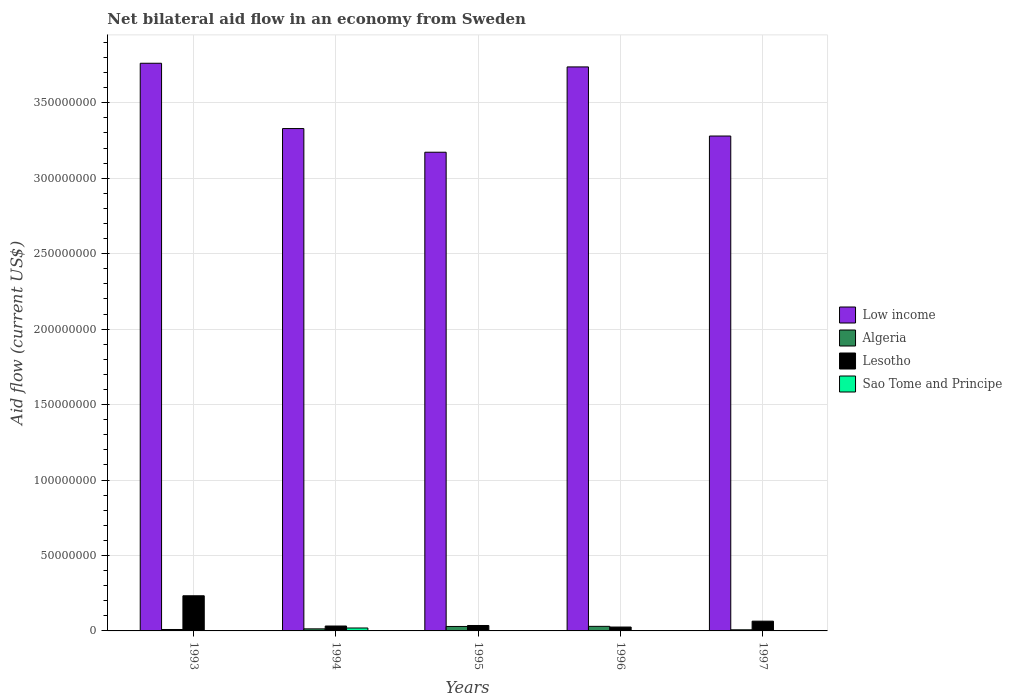How many different coloured bars are there?
Offer a terse response. 4. How many groups of bars are there?
Your answer should be compact. 5. How many bars are there on the 2nd tick from the left?
Provide a succinct answer. 4. How many bars are there on the 5th tick from the right?
Give a very brief answer. 4. In how many cases, is the number of bars for a given year not equal to the number of legend labels?
Offer a very short reply. 0. What is the net bilateral aid flow in Algeria in 1996?
Keep it short and to the point. 3.03e+06. Across all years, what is the maximum net bilateral aid flow in Low income?
Keep it short and to the point. 3.76e+08. Across all years, what is the minimum net bilateral aid flow in Low income?
Ensure brevity in your answer.  3.17e+08. In which year was the net bilateral aid flow in Sao Tome and Principe minimum?
Provide a succinct answer. 1993. What is the total net bilateral aid flow in Sao Tome and Principe in the graph?
Keep it short and to the point. 2.18e+06. What is the difference between the net bilateral aid flow in Sao Tome and Principe in 1993 and that in 1995?
Offer a very short reply. -4.00e+04. What is the difference between the net bilateral aid flow in Algeria in 1996 and the net bilateral aid flow in Low income in 1995?
Keep it short and to the point. -3.14e+08. What is the average net bilateral aid flow in Sao Tome and Principe per year?
Offer a very short reply. 4.36e+05. In the year 1994, what is the difference between the net bilateral aid flow in Algeria and net bilateral aid flow in Low income?
Provide a succinct answer. -3.32e+08. In how many years, is the net bilateral aid flow in Sao Tome and Principe greater than 80000000 US$?
Provide a succinct answer. 0. What is the ratio of the net bilateral aid flow in Algeria in 1993 to that in 1996?
Your answer should be very brief. 0.31. Is the net bilateral aid flow in Algeria in 1994 less than that in 1997?
Your answer should be compact. No. What is the difference between the highest and the second highest net bilateral aid flow in Lesotho?
Give a very brief answer. 1.68e+07. What is the difference between the highest and the lowest net bilateral aid flow in Low income?
Your response must be concise. 5.90e+07. Is the sum of the net bilateral aid flow in Algeria in 1994 and 1995 greater than the maximum net bilateral aid flow in Low income across all years?
Your answer should be compact. No. What does the 3rd bar from the left in 1994 represents?
Offer a terse response. Lesotho. What does the 3rd bar from the right in 1997 represents?
Give a very brief answer. Algeria. Are all the bars in the graph horizontal?
Offer a terse response. No. How many years are there in the graph?
Provide a short and direct response. 5. What is the difference between two consecutive major ticks on the Y-axis?
Keep it short and to the point. 5.00e+07. Are the values on the major ticks of Y-axis written in scientific E-notation?
Your answer should be very brief. No. Does the graph contain any zero values?
Ensure brevity in your answer.  No. Does the graph contain grids?
Provide a succinct answer. Yes. How many legend labels are there?
Give a very brief answer. 4. How are the legend labels stacked?
Your answer should be very brief. Vertical. What is the title of the graph?
Your answer should be very brief. Net bilateral aid flow in an economy from Sweden. What is the Aid flow (current US$) in Low income in 1993?
Your answer should be compact. 3.76e+08. What is the Aid flow (current US$) in Algeria in 1993?
Keep it short and to the point. 9.50e+05. What is the Aid flow (current US$) in Lesotho in 1993?
Provide a short and direct response. 2.33e+07. What is the Aid flow (current US$) of Sao Tome and Principe in 1993?
Provide a succinct answer. 4.00e+04. What is the Aid flow (current US$) in Low income in 1994?
Your answer should be compact. 3.33e+08. What is the Aid flow (current US$) in Algeria in 1994?
Your answer should be very brief. 1.37e+06. What is the Aid flow (current US$) in Lesotho in 1994?
Your response must be concise. 3.25e+06. What is the Aid flow (current US$) in Sao Tome and Principe in 1994?
Offer a terse response. 1.94e+06. What is the Aid flow (current US$) in Low income in 1995?
Your answer should be very brief. 3.17e+08. What is the Aid flow (current US$) in Algeria in 1995?
Your answer should be very brief. 2.96e+06. What is the Aid flow (current US$) of Lesotho in 1995?
Provide a succinct answer. 3.60e+06. What is the Aid flow (current US$) of Sao Tome and Principe in 1995?
Your answer should be very brief. 8.00e+04. What is the Aid flow (current US$) of Low income in 1996?
Ensure brevity in your answer.  3.74e+08. What is the Aid flow (current US$) of Algeria in 1996?
Keep it short and to the point. 3.03e+06. What is the Aid flow (current US$) of Lesotho in 1996?
Make the answer very short. 2.57e+06. What is the Aid flow (current US$) in Low income in 1997?
Make the answer very short. 3.28e+08. What is the Aid flow (current US$) in Algeria in 1997?
Keep it short and to the point. 7.40e+05. What is the Aid flow (current US$) of Lesotho in 1997?
Provide a succinct answer. 6.47e+06. Across all years, what is the maximum Aid flow (current US$) in Low income?
Your answer should be compact. 3.76e+08. Across all years, what is the maximum Aid flow (current US$) in Algeria?
Offer a very short reply. 3.03e+06. Across all years, what is the maximum Aid flow (current US$) of Lesotho?
Give a very brief answer. 2.33e+07. Across all years, what is the maximum Aid flow (current US$) in Sao Tome and Principe?
Provide a short and direct response. 1.94e+06. Across all years, what is the minimum Aid flow (current US$) in Low income?
Your response must be concise. 3.17e+08. Across all years, what is the minimum Aid flow (current US$) in Algeria?
Make the answer very short. 7.40e+05. Across all years, what is the minimum Aid flow (current US$) of Lesotho?
Make the answer very short. 2.57e+06. What is the total Aid flow (current US$) of Low income in the graph?
Provide a succinct answer. 1.73e+09. What is the total Aid flow (current US$) of Algeria in the graph?
Your response must be concise. 9.05e+06. What is the total Aid flow (current US$) in Lesotho in the graph?
Ensure brevity in your answer.  3.92e+07. What is the total Aid flow (current US$) in Sao Tome and Principe in the graph?
Provide a succinct answer. 2.18e+06. What is the difference between the Aid flow (current US$) of Low income in 1993 and that in 1994?
Keep it short and to the point. 4.33e+07. What is the difference between the Aid flow (current US$) in Algeria in 1993 and that in 1994?
Your response must be concise. -4.20e+05. What is the difference between the Aid flow (current US$) in Lesotho in 1993 and that in 1994?
Offer a very short reply. 2.00e+07. What is the difference between the Aid flow (current US$) of Sao Tome and Principe in 1993 and that in 1994?
Your answer should be very brief. -1.90e+06. What is the difference between the Aid flow (current US$) in Low income in 1993 and that in 1995?
Keep it short and to the point. 5.90e+07. What is the difference between the Aid flow (current US$) in Algeria in 1993 and that in 1995?
Your answer should be very brief. -2.01e+06. What is the difference between the Aid flow (current US$) of Lesotho in 1993 and that in 1995?
Your answer should be compact. 1.97e+07. What is the difference between the Aid flow (current US$) of Low income in 1993 and that in 1996?
Offer a terse response. 2.42e+06. What is the difference between the Aid flow (current US$) in Algeria in 1993 and that in 1996?
Your answer should be very brief. -2.08e+06. What is the difference between the Aid flow (current US$) of Lesotho in 1993 and that in 1996?
Provide a short and direct response. 2.07e+07. What is the difference between the Aid flow (current US$) in Sao Tome and Principe in 1993 and that in 1996?
Offer a very short reply. -4.00e+04. What is the difference between the Aid flow (current US$) of Low income in 1993 and that in 1997?
Keep it short and to the point. 4.82e+07. What is the difference between the Aid flow (current US$) of Lesotho in 1993 and that in 1997?
Offer a very short reply. 1.68e+07. What is the difference between the Aid flow (current US$) in Sao Tome and Principe in 1993 and that in 1997?
Your answer should be very brief. 0. What is the difference between the Aid flow (current US$) of Low income in 1994 and that in 1995?
Ensure brevity in your answer.  1.57e+07. What is the difference between the Aid flow (current US$) of Algeria in 1994 and that in 1995?
Offer a terse response. -1.59e+06. What is the difference between the Aid flow (current US$) of Lesotho in 1994 and that in 1995?
Offer a terse response. -3.50e+05. What is the difference between the Aid flow (current US$) of Sao Tome and Principe in 1994 and that in 1995?
Make the answer very short. 1.86e+06. What is the difference between the Aid flow (current US$) in Low income in 1994 and that in 1996?
Provide a short and direct response. -4.08e+07. What is the difference between the Aid flow (current US$) in Algeria in 1994 and that in 1996?
Ensure brevity in your answer.  -1.66e+06. What is the difference between the Aid flow (current US$) of Lesotho in 1994 and that in 1996?
Offer a terse response. 6.80e+05. What is the difference between the Aid flow (current US$) of Sao Tome and Principe in 1994 and that in 1996?
Offer a very short reply. 1.86e+06. What is the difference between the Aid flow (current US$) of Low income in 1994 and that in 1997?
Provide a succinct answer. 4.95e+06. What is the difference between the Aid flow (current US$) of Algeria in 1994 and that in 1997?
Your response must be concise. 6.30e+05. What is the difference between the Aid flow (current US$) of Lesotho in 1994 and that in 1997?
Ensure brevity in your answer.  -3.22e+06. What is the difference between the Aid flow (current US$) in Sao Tome and Principe in 1994 and that in 1997?
Your answer should be compact. 1.90e+06. What is the difference between the Aid flow (current US$) of Low income in 1995 and that in 1996?
Ensure brevity in your answer.  -5.65e+07. What is the difference between the Aid flow (current US$) in Lesotho in 1995 and that in 1996?
Offer a very short reply. 1.03e+06. What is the difference between the Aid flow (current US$) of Sao Tome and Principe in 1995 and that in 1996?
Keep it short and to the point. 0. What is the difference between the Aid flow (current US$) of Low income in 1995 and that in 1997?
Provide a short and direct response. -1.07e+07. What is the difference between the Aid flow (current US$) in Algeria in 1995 and that in 1997?
Make the answer very short. 2.22e+06. What is the difference between the Aid flow (current US$) in Lesotho in 1995 and that in 1997?
Your answer should be very brief. -2.87e+06. What is the difference between the Aid flow (current US$) in Low income in 1996 and that in 1997?
Provide a succinct answer. 4.58e+07. What is the difference between the Aid flow (current US$) of Algeria in 1996 and that in 1997?
Offer a terse response. 2.29e+06. What is the difference between the Aid flow (current US$) of Lesotho in 1996 and that in 1997?
Give a very brief answer. -3.90e+06. What is the difference between the Aid flow (current US$) in Low income in 1993 and the Aid flow (current US$) in Algeria in 1994?
Offer a terse response. 3.75e+08. What is the difference between the Aid flow (current US$) in Low income in 1993 and the Aid flow (current US$) in Lesotho in 1994?
Keep it short and to the point. 3.73e+08. What is the difference between the Aid flow (current US$) of Low income in 1993 and the Aid flow (current US$) of Sao Tome and Principe in 1994?
Provide a succinct answer. 3.74e+08. What is the difference between the Aid flow (current US$) of Algeria in 1993 and the Aid flow (current US$) of Lesotho in 1994?
Offer a terse response. -2.30e+06. What is the difference between the Aid flow (current US$) in Algeria in 1993 and the Aid flow (current US$) in Sao Tome and Principe in 1994?
Your response must be concise. -9.90e+05. What is the difference between the Aid flow (current US$) of Lesotho in 1993 and the Aid flow (current US$) of Sao Tome and Principe in 1994?
Your answer should be compact. 2.14e+07. What is the difference between the Aid flow (current US$) of Low income in 1993 and the Aid flow (current US$) of Algeria in 1995?
Ensure brevity in your answer.  3.73e+08. What is the difference between the Aid flow (current US$) in Low income in 1993 and the Aid flow (current US$) in Lesotho in 1995?
Your answer should be very brief. 3.73e+08. What is the difference between the Aid flow (current US$) of Low income in 1993 and the Aid flow (current US$) of Sao Tome and Principe in 1995?
Offer a terse response. 3.76e+08. What is the difference between the Aid flow (current US$) in Algeria in 1993 and the Aid flow (current US$) in Lesotho in 1995?
Your answer should be compact. -2.65e+06. What is the difference between the Aid flow (current US$) of Algeria in 1993 and the Aid flow (current US$) of Sao Tome and Principe in 1995?
Your response must be concise. 8.70e+05. What is the difference between the Aid flow (current US$) in Lesotho in 1993 and the Aid flow (current US$) in Sao Tome and Principe in 1995?
Offer a terse response. 2.32e+07. What is the difference between the Aid flow (current US$) in Low income in 1993 and the Aid flow (current US$) in Algeria in 1996?
Keep it short and to the point. 3.73e+08. What is the difference between the Aid flow (current US$) of Low income in 1993 and the Aid flow (current US$) of Lesotho in 1996?
Your answer should be compact. 3.74e+08. What is the difference between the Aid flow (current US$) of Low income in 1993 and the Aid flow (current US$) of Sao Tome and Principe in 1996?
Provide a succinct answer. 3.76e+08. What is the difference between the Aid flow (current US$) of Algeria in 1993 and the Aid flow (current US$) of Lesotho in 1996?
Provide a succinct answer. -1.62e+06. What is the difference between the Aid flow (current US$) in Algeria in 1993 and the Aid flow (current US$) in Sao Tome and Principe in 1996?
Give a very brief answer. 8.70e+05. What is the difference between the Aid flow (current US$) of Lesotho in 1993 and the Aid flow (current US$) of Sao Tome and Principe in 1996?
Ensure brevity in your answer.  2.32e+07. What is the difference between the Aid flow (current US$) of Low income in 1993 and the Aid flow (current US$) of Algeria in 1997?
Provide a short and direct response. 3.75e+08. What is the difference between the Aid flow (current US$) in Low income in 1993 and the Aid flow (current US$) in Lesotho in 1997?
Provide a succinct answer. 3.70e+08. What is the difference between the Aid flow (current US$) in Low income in 1993 and the Aid flow (current US$) in Sao Tome and Principe in 1997?
Offer a very short reply. 3.76e+08. What is the difference between the Aid flow (current US$) of Algeria in 1993 and the Aid flow (current US$) of Lesotho in 1997?
Ensure brevity in your answer.  -5.52e+06. What is the difference between the Aid flow (current US$) in Algeria in 1993 and the Aid flow (current US$) in Sao Tome and Principe in 1997?
Ensure brevity in your answer.  9.10e+05. What is the difference between the Aid flow (current US$) in Lesotho in 1993 and the Aid flow (current US$) in Sao Tome and Principe in 1997?
Provide a succinct answer. 2.32e+07. What is the difference between the Aid flow (current US$) in Low income in 1994 and the Aid flow (current US$) in Algeria in 1995?
Keep it short and to the point. 3.30e+08. What is the difference between the Aid flow (current US$) in Low income in 1994 and the Aid flow (current US$) in Lesotho in 1995?
Make the answer very short. 3.29e+08. What is the difference between the Aid flow (current US$) of Low income in 1994 and the Aid flow (current US$) of Sao Tome and Principe in 1995?
Offer a very short reply. 3.33e+08. What is the difference between the Aid flow (current US$) of Algeria in 1994 and the Aid flow (current US$) of Lesotho in 1995?
Provide a succinct answer. -2.23e+06. What is the difference between the Aid flow (current US$) of Algeria in 1994 and the Aid flow (current US$) of Sao Tome and Principe in 1995?
Your answer should be very brief. 1.29e+06. What is the difference between the Aid flow (current US$) of Lesotho in 1994 and the Aid flow (current US$) of Sao Tome and Principe in 1995?
Keep it short and to the point. 3.17e+06. What is the difference between the Aid flow (current US$) in Low income in 1994 and the Aid flow (current US$) in Algeria in 1996?
Offer a terse response. 3.30e+08. What is the difference between the Aid flow (current US$) of Low income in 1994 and the Aid flow (current US$) of Lesotho in 1996?
Your response must be concise. 3.30e+08. What is the difference between the Aid flow (current US$) of Low income in 1994 and the Aid flow (current US$) of Sao Tome and Principe in 1996?
Make the answer very short. 3.33e+08. What is the difference between the Aid flow (current US$) of Algeria in 1994 and the Aid flow (current US$) of Lesotho in 1996?
Give a very brief answer. -1.20e+06. What is the difference between the Aid flow (current US$) in Algeria in 1994 and the Aid flow (current US$) in Sao Tome and Principe in 1996?
Give a very brief answer. 1.29e+06. What is the difference between the Aid flow (current US$) in Lesotho in 1994 and the Aid flow (current US$) in Sao Tome and Principe in 1996?
Your answer should be very brief. 3.17e+06. What is the difference between the Aid flow (current US$) of Low income in 1994 and the Aid flow (current US$) of Algeria in 1997?
Your answer should be compact. 3.32e+08. What is the difference between the Aid flow (current US$) in Low income in 1994 and the Aid flow (current US$) in Lesotho in 1997?
Your answer should be compact. 3.26e+08. What is the difference between the Aid flow (current US$) of Low income in 1994 and the Aid flow (current US$) of Sao Tome and Principe in 1997?
Provide a succinct answer. 3.33e+08. What is the difference between the Aid flow (current US$) of Algeria in 1994 and the Aid flow (current US$) of Lesotho in 1997?
Offer a terse response. -5.10e+06. What is the difference between the Aid flow (current US$) of Algeria in 1994 and the Aid flow (current US$) of Sao Tome and Principe in 1997?
Provide a succinct answer. 1.33e+06. What is the difference between the Aid flow (current US$) in Lesotho in 1994 and the Aid flow (current US$) in Sao Tome and Principe in 1997?
Give a very brief answer. 3.21e+06. What is the difference between the Aid flow (current US$) in Low income in 1995 and the Aid flow (current US$) in Algeria in 1996?
Your answer should be very brief. 3.14e+08. What is the difference between the Aid flow (current US$) in Low income in 1995 and the Aid flow (current US$) in Lesotho in 1996?
Your response must be concise. 3.15e+08. What is the difference between the Aid flow (current US$) of Low income in 1995 and the Aid flow (current US$) of Sao Tome and Principe in 1996?
Your response must be concise. 3.17e+08. What is the difference between the Aid flow (current US$) in Algeria in 1995 and the Aid flow (current US$) in Sao Tome and Principe in 1996?
Ensure brevity in your answer.  2.88e+06. What is the difference between the Aid flow (current US$) in Lesotho in 1995 and the Aid flow (current US$) in Sao Tome and Principe in 1996?
Your answer should be compact. 3.52e+06. What is the difference between the Aid flow (current US$) in Low income in 1995 and the Aid flow (current US$) in Algeria in 1997?
Your response must be concise. 3.16e+08. What is the difference between the Aid flow (current US$) in Low income in 1995 and the Aid flow (current US$) in Lesotho in 1997?
Offer a terse response. 3.11e+08. What is the difference between the Aid flow (current US$) of Low income in 1995 and the Aid flow (current US$) of Sao Tome and Principe in 1997?
Make the answer very short. 3.17e+08. What is the difference between the Aid flow (current US$) of Algeria in 1995 and the Aid flow (current US$) of Lesotho in 1997?
Offer a very short reply. -3.51e+06. What is the difference between the Aid flow (current US$) in Algeria in 1995 and the Aid flow (current US$) in Sao Tome and Principe in 1997?
Provide a succinct answer. 2.92e+06. What is the difference between the Aid flow (current US$) of Lesotho in 1995 and the Aid flow (current US$) of Sao Tome and Principe in 1997?
Ensure brevity in your answer.  3.56e+06. What is the difference between the Aid flow (current US$) of Low income in 1996 and the Aid flow (current US$) of Algeria in 1997?
Your answer should be very brief. 3.73e+08. What is the difference between the Aid flow (current US$) of Low income in 1996 and the Aid flow (current US$) of Lesotho in 1997?
Keep it short and to the point. 3.67e+08. What is the difference between the Aid flow (current US$) of Low income in 1996 and the Aid flow (current US$) of Sao Tome and Principe in 1997?
Provide a short and direct response. 3.74e+08. What is the difference between the Aid flow (current US$) of Algeria in 1996 and the Aid flow (current US$) of Lesotho in 1997?
Your answer should be compact. -3.44e+06. What is the difference between the Aid flow (current US$) in Algeria in 1996 and the Aid flow (current US$) in Sao Tome and Principe in 1997?
Offer a terse response. 2.99e+06. What is the difference between the Aid flow (current US$) of Lesotho in 1996 and the Aid flow (current US$) of Sao Tome and Principe in 1997?
Offer a very short reply. 2.53e+06. What is the average Aid flow (current US$) of Low income per year?
Offer a terse response. 3.46e+08. What is the average Aid flow (current US$) of Algeria per year?
Give a very brief answer. 1.81e+06. What is the average Aid flow (current US$) in Lesotho per year?
Offer a very short reply. 7.84e+06. What is the average Aid flow (current US$) of Sao Tome and Principe per year?
Keep it short and to the point. 4.36e+05. In the year 1993, what is the difference between the Aid flow (current US$) in Low income and Aid flow (current US$) in Algeria?
Offer a terse response. 3.75e+08. In the year 1993, what is the difference between the Aid flow (current US$) in Low income and Aid flow (current US$) in Lesotho?
Provide a succinct answer. 3.53e+08. In the year 1993, what is the difference between the Aid flow (current US$) of Low income and Aid flow (current US$) of Sao Tome and Principe?
Your answer should be compact. 3.76e+08. In the year 1993, what is the difference between the Aid flow (current US$) in Algeria and Aid flow (current US$) in Lesotho?
Your answer should be compact. -2.23e+07. In the year 1993, what is the difference between the Aid flow (current US$) in Algeria and Aid flow (current US$) in Sao Tome and Principe?
Offer a terse response. 9.10e+05. In the year 1993, what is the difference between the Aid flow (current US$) in Lesotho and Aid flow (current US$) in Sao Tome and Principe?
Keep it short and to the point. 2.32e+07. In the year 1994, what is the difference between the Aid flow (current US$) in Low income and Aid flow (current US$) in Algeria?
Keep it short and to the point. 3.32e+08. In the year 1994, what is the difference between the Aid flow (current US$) in Low income and Aid flow (current US$) in Lesotho?
Offer a very short reply. 3.30e+08. In the year 1994, what is the difference between the Aid flow (current US$) of Low income and Aid flow (current US$) of Sao Tome and Principe?
Offer a terse response. 3.31e+08. In the year 1994, what is the difference between the Aid flow (current US$) of Algeria and Aid flow (current US$) of Lesotho?
Your response must be concise. -1.88e+06. In the year 1994, what is the difference between the Aid flow (current US$) in Algeria and Aid flow (current US$) in Sao Tome and Principe?
Provide a succinct answer. -5.70e+05. In the year 1994, what is the difference between the Aid flow (current US$) in Lesotho and Aid flow (current US$) in Sao Tome and Principe?
Your response must be concise. 1.31e+06. In the year 1995, what is the difference between the Aid flow (current US$) of Low income and Aid flow (current US$) of Algeria?
Make the answer very short. 3.14e+08. In the year 1995, what is the difference between the Aid flow (current US$) in Low income and Aid flow (current US$) in Lesotho?
Provide a short and direct response. 3.14e+08. In the year 1995, what is the difference between the Aid flow (current US$) in Low income and Aid flow (current US$) in Sao Tome and Principe?
Make the answer very short. 3.17e+08. In the year 1995, what is the difference between the Aid flow (current US$) in Algeria and Aid flow (current US$) in Lesotho?
Offer a terse response. -6.40e+05. In the year 1995, what is the difference between the Aid flow (current US$) in Algeria and Aid flow (current US$) in Sao Tome and Principe?
Keep it short and to the point. 2.88e+06. In the year 1995, what is the difference between the Aid flow (current US$) of Lesotho and Aid flow (current US$) of Sao Tome and Principe?
Provide a succinct answer. 3.52e+06. In the year 1996, what is the difference between the Aid flow (current US$) in Low income and Aid flow (current US$) in Algeria?
Ensure brevity in your answer.  3.71e+08. In the year 1996, what is the difference between the Aid flow (current US$) of Low income and Aid flow (current US$) of Lesotho?
Ensure brevity in your answer.  3.71e+08. In the year 1996, what is the difference between the Aid flow (current US$) in Low income and Aid flow (current US$) in Sao Tome and Principe?
Give a very brief answer. 3.74e+08. In the year 1996, what is the difference between the Aid flow (current US$) in Algeria and Aid flow (current US$) in Lesotho?
Keep it short and to the point. 4.60e+05. In the year 1996, what is the difference between the Aid flow (current US$) in Algeria and Aid flow (current US$) in Sao Tome and Principe?
Offer a terse response. 2.95e+06. In the year 1996, what is the difference between the Aid flow (current US$) in Lesotho and Aid flow (current US$) in Sao Tome and Principe?
Provide a short and direct response. 2.49e+06. In the year 1997, what is the difference between the Aid flow (current US$) of Low income and Aid flow (current US$) of Algeria?
Offer a terse response. 3.27e+08. In the year 1997, what is the difference between the Aid flow (current US$) in Low income and Aid flow (current US$) in Lesotho?
Offer a terse response. 3.22e+08. In the year 1997, what is the difference between the Aid flow (current US$) in Low income and Aid flow (current US$) in Sao Tome and Principe?
Make the answer very short. 3.28e+08. In the year 1997, what is the difference between the Aid flow (current US$) in Algeria and Aid flow (current US$) in Lesotho?
Offer a terse response. -5.73e+06. In the year 1997, what is the difference between the Aid flow (current US$) in Algeria and Aid flow (current US$) in Sao Tome and Principe?
Give a very brief answer. 7.00e+05. In the year 1997, what is the difference between the Aid flow (current US$) of Lesotho and Aid flow (current US$) of Sao Tome and Principe?
Ensure brevity in your answer.  6.43e+06. What is the ratio of the Aid flow (current US$) of Low income in 1993 to that in 1994?
Make the answer very short. 1.13. What is the ratio of the Aid flow (current US$) in Algeria in 1993 to that in 1994?
Your answer should be very brief. 0.69. What is the ratio of the Aid flow (current US$) of Lesotho in 1993 to that in 1994?
Ensure brevity in your answer.  7.17. What is the ratio of the Aid flow (current US$) in Sao Tome and Principe in 1993 to that in 1994?
Ensure brevity in your answer.  0.02. What is the ratio of the Aid flow (current US$) of Low income in 1993 to that in 1995?
Offer a terse response. 1.19. What is the ratio of the Aid flow (current US$) of Algeria in 1993 to that in 1995?
Your answer should be very brief. 0.32. What is the ratio of the Aid flow (current US$) of Lesotho in 1993 to that in 1995?
Provide a short and direct response. 6.47. What is the ratio of the Aid flow (current US$) in Sao Tome and Principe in 1993 to that in 1995?
Provide a succinct answer. 0.5. What is the ratio of the Aid flow (current US$) in Low income in 1993 to that in 1996?
Offer a terse response. 1.01. What is the ratio of the Aid flow (current US$) of Algeria in 1993 to that in 1996?
Provide a succinct answer. 0.31. What is the ratio of the Aid flow (current US$) in Lesotho in 1993 to that in 1996?
Give a very brief answer. 9.06. What is the ratio of the Aid flow (current US$) in Sao Tome and Principe in 1993 to that in 1996?
Keep it short and to the point. 0.5. What is the ratio of the Aid flow (current US$) of Low income in 1993 to that in 1997?
Keep it short and to the point. 1.15. What is the ratio of the Aid flow (current US$) in Algeria in 1993 to that in 1997?
Your response must be concise. 1.28. What is the ratio of the Aid flow (current US$) of Lesotho in 1993 to that in 1997?
Ensure brevity in your answer.  3.6. What is the ratio of the Aid flow (current US$) in Sao Tome and Principe in 1993 to that in 1997?
Offer a very short reply. 1. What is the ratio of the Aid flow (current US$) of Low income in 1994 to that in 1995?
Your answer should be very brief. 1.05. What is the ratio of the Aid flow (current US$) of Algeria in 1994 to that in 1995?
Your answer should be compact. 0.46. What is the ratio of the Aid flow (current US$) in Lesotho in 1994 to that in 1995?
Provide a short and direct response. 0.9. What is the ratio of the Aid flow (current US$) of Sao Tome and Principe in 1994 to that in 1995?
Give a very brief answer. 24.25. What is the ratio of the Aid flow (current US$) in Low income in 1994 to that in 1996?
Make the answer very short. 0.89. What is the ratio of the Aid flow (current US$) of Algeria in 1994 to that in 1996?
Offer a very short reply. 0.45. What is the ratio of the Aid flow (current US$) of Lesotho in 1994 to that in 1996?
Offer a terse response. 1.26. What is the ratio of the Aid flow (current US$) in Sao Tome and Principe in 1994 to that in 1996?
Your answer should be very brief. 24.25. What is the ratio of the Aid flow (current US$) of Low income in 1994 to that in 1997?
Give a very brief answer. 1.02. What is the ratio of the Aid flow (current US$) in Algeria in 1994 to that in 1997?
Your response must be concise. 1.85. What is the ratio of the Aid flow (current US$) in Lesotho in 1994 to that in 1997?
Keep it short and to the point. 0.5. What is the ratio of the Aid flow (current US$) of Sao Tome and Principe in 1994 to that in 1997?
Offer a very short reply. 48.5. What is the ratio of the Aid flow (current US$) of Low income in 1995 to that in 1996?
Give a very brief answer. 0.85. What is the ratio of the Aid flow (current US$) of Algeria in 1995 to that in 1996?
Offer a very short reply. 0.98. What is the ratio of the Aid flow (current US$) in Lesotho in 1995 to that in 1996?
Make the answer very short. 1.4. What is the ratio of the Aid flow (current US$) of Sao Tome and Principe in 1995 to that in 1996?
Your answer should be compact. 1. What is the ratio of the Aid flow (current US$) in Low income in 1995 to that in 1997?
Your answer should be very brief. 0.97. What is the ratio of the Aid flow (current US$) in Lesotho in 1995 to that in 1997?
Keep it short and to the point. 0.56. What is the ratio of the Aid flow (current US$) in Low income in 1996 to that in 1997?
Provide a short and direct response. 1.14. What is the ratio of the Aid flow (current US$) of Algeria in 1996 to that in 1997?
Make the answer very short. 4.09. What is the ratio of the Aid flow (current US$) of Lesotho in 1996 to that in 1997?
Provide a succinct answer. 0.4. What is the difference between the highest and the second highest Aid flow (current US$) in Low income?
Ensure brevity in your answer.  2.42e+06. What is the difference between the highest and the second highest Aid flow (current US$) in Lesotho?
Your answer should be very brief. 1.68e+07. What is the difference between the highest and the second highest Aid flow (current US$) of Sao Tome and Principe?
Give a very brief answer. 1.86e+06. What is the difference between the highest and the lowest Aid flow (current US$) in Low income?
Provide a short and direct response. 5.90e+07. What is the difference between the highest and the lowest Aid flow (current US$) of Algeria?
Ensure brevity in your answer.  2.29e+06. What is the difference between the highest and the lowest Aid flow (current US$) of Lesotho?
Offer a terse response. 2.07e+07. What is the difference between the highest and the lowest Aid flow (current US$) in Sao Tome and Principe?
Ensure brevity in your answer.  1.90e+06. 